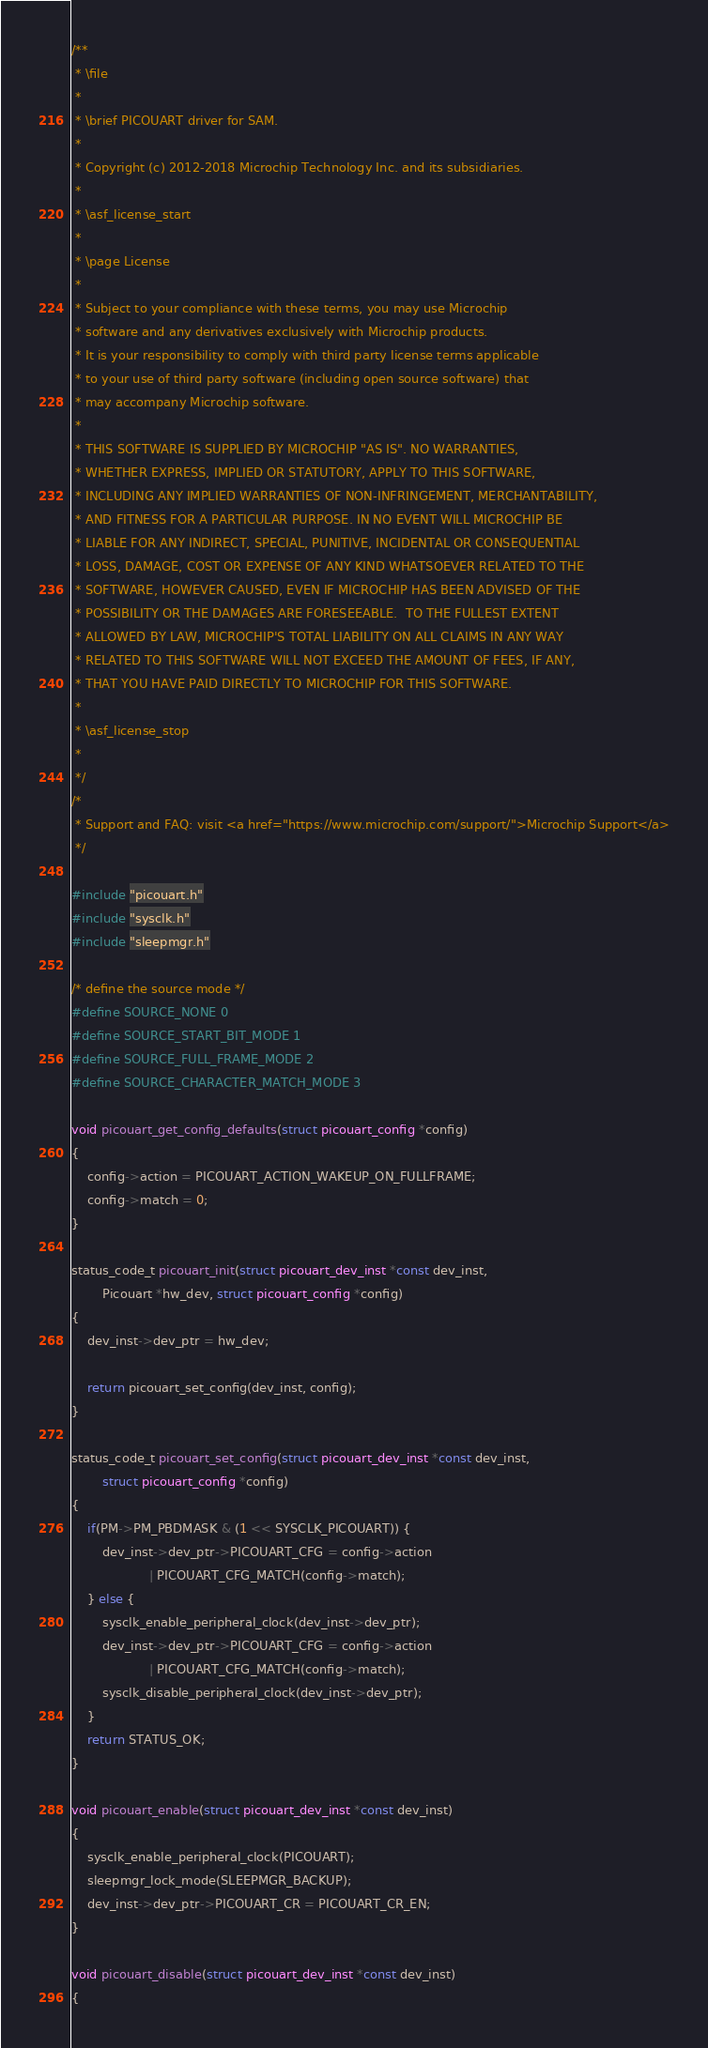<code> <loc_0><loc_0><loc_500><loc_500><_C_>/**
 * \file
 *
 * \brief PICOUART driver for SAM.
 *
 * Copyright (c) 2012-2018 Microchip Technology Inc. and its subsidiaries.
 *
 * \asf_license_start
 *
 * \page License
 *
 * Subject to your compliance with these terms, you may use Microchip
 * software and any derivatives exclusively with Microchip products.
 * It is your responsibility to comply with third party license terms applicable
 * to your use of third party software (including open source software) that
 * may accompany Microchip software.
 *
 * THIS SOFTWARE IS SUPPLIED BY MICROCHIP "AS IS". NO WARRANTIES,
 * WHETHER EXPRESS, IMPLIED OR STATUTORY, APPLY TO THIS SOFTWARE,
 * INCLUDING ANY IMPLIED WARRANTIES OF NON-INFRINGEMENT, MERCHANTABILITY,
 * AND FITNESS FOR A PARTICULAR PURPOSE. IN NO EVENT WILL MICROCHIP BE
 * LIABLE FOR ANY INDIRECT, SPECIAL, PUNITIVE, INCIDENTAL OR CONSEQUENTIAL
 * LOSS, DAMAGE, COST OR EXPENSE OF ANY KIND WHATSOEVER RELATED TO THE
 * SOFTWARE, HOWEVER CAUSED, EVEN IF MICROCHIP HAS BEEN ADVISED OF THE
 * POSSIBILITY OR THE DAMAGES ARE FORESEEABLE.  TO THE FULLEST EXTENT
 * ALLOWED BY LAW, MICROCHIP'S TOTAL LIABILITY ON ALL CLAIMS IN ANY WAY
 * RELATED TO THIS SOFTWARE WILL NOT EXCEED THE AMOUNT OF FEES, IF ANY,
 * THAT YOU HAVE PAID DIRECTLY TO MICROCHIP FOR THIS SOFTWARE.
 *
 * \asf_license_stop
 *
 */
/*
 * Support and FAQ: visit <a href="https://www.microchip.com/support/">Microchip Support</a>
 */

#include "picouart.h"
#include "sysclk.h"
#include "sleepmgr.h"

/* define the source mode */
#define SOURCE_NONE 0
#define SOURCE_START_BIT_MODE 1
#define SOURCE_FULL_FRAME_MODE 2
#define SOURCE_CHARACTER_MATCH_MODE 3

void picouart_get_config_defaults(struct picouart_config *config)
{
	config->action = PICOUART_ACTION_WAKEUP_ON_FULLFRAME;
	config->match = 0;
}

status_code_t picouart_init(struct picouart_dev_inst *const dev_inst, 
		Picouart *hw_dev, struct picouart_config *config)
{
	dev_inst->dev_ptr = hw_dev;

	return picouart_set_config(dev_inst, config);
}

status_code_t picouart_set_config(struct picouart_dev_inst *const dev_inst,
		struct picouart_config *config)
{
	if(PM->PM_PBDMASK & (1 << SYSCLK_PICOUART)) {
		dev_inst->dev_ptr->PICOUART_CFG = config->action
					| PICOUART_CFG_MATCH(config->match);
	} else {
		sysclk_enable_peripheral_clock(dev_inst->dev_ptr);
		dev_inst->dev_ptr->PICOUART_CFG = config->action
					| PICOUART_CFG_MATCH(config->match);
		sysclk_disable_peripheral_clock(dev_inst->dev_ptr);
	}
	return STATUS_OK;
}

void picouart_enable(struct picouart_dev_inst *const dev_inst)
{
	sysclk_enable_peripheral_clock(PICOUART);
	sleepmgr_lock_mode(SLEEPMGR_BACKUP);
	dev_inst->dev_ptr->PICOUART_CR = PICOUART_CR_EN;
}

void picouart_disable(struct picouart_dev_inst *const dev_inst)
{</code> 